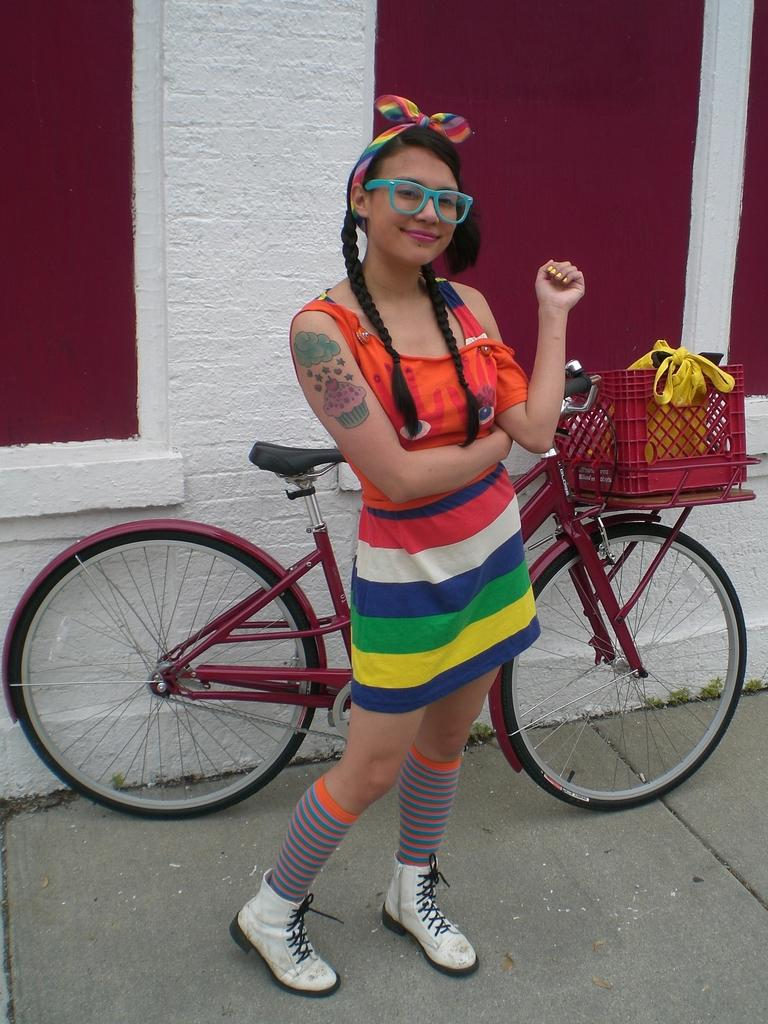What is the main subject of the image? The main subject of the image is a woman standing on the floor. What can be seen behind the woman? There is a bicycle on the wall behind the woman. Are there any objects on the bicycle? Yes, there is a box with objects on the bicycle. What type of income can be seen in the image? There is no reference to income in the image; it features a woman standing on the floor with a bicycle on the wall and a box with objects on the bicycle. 